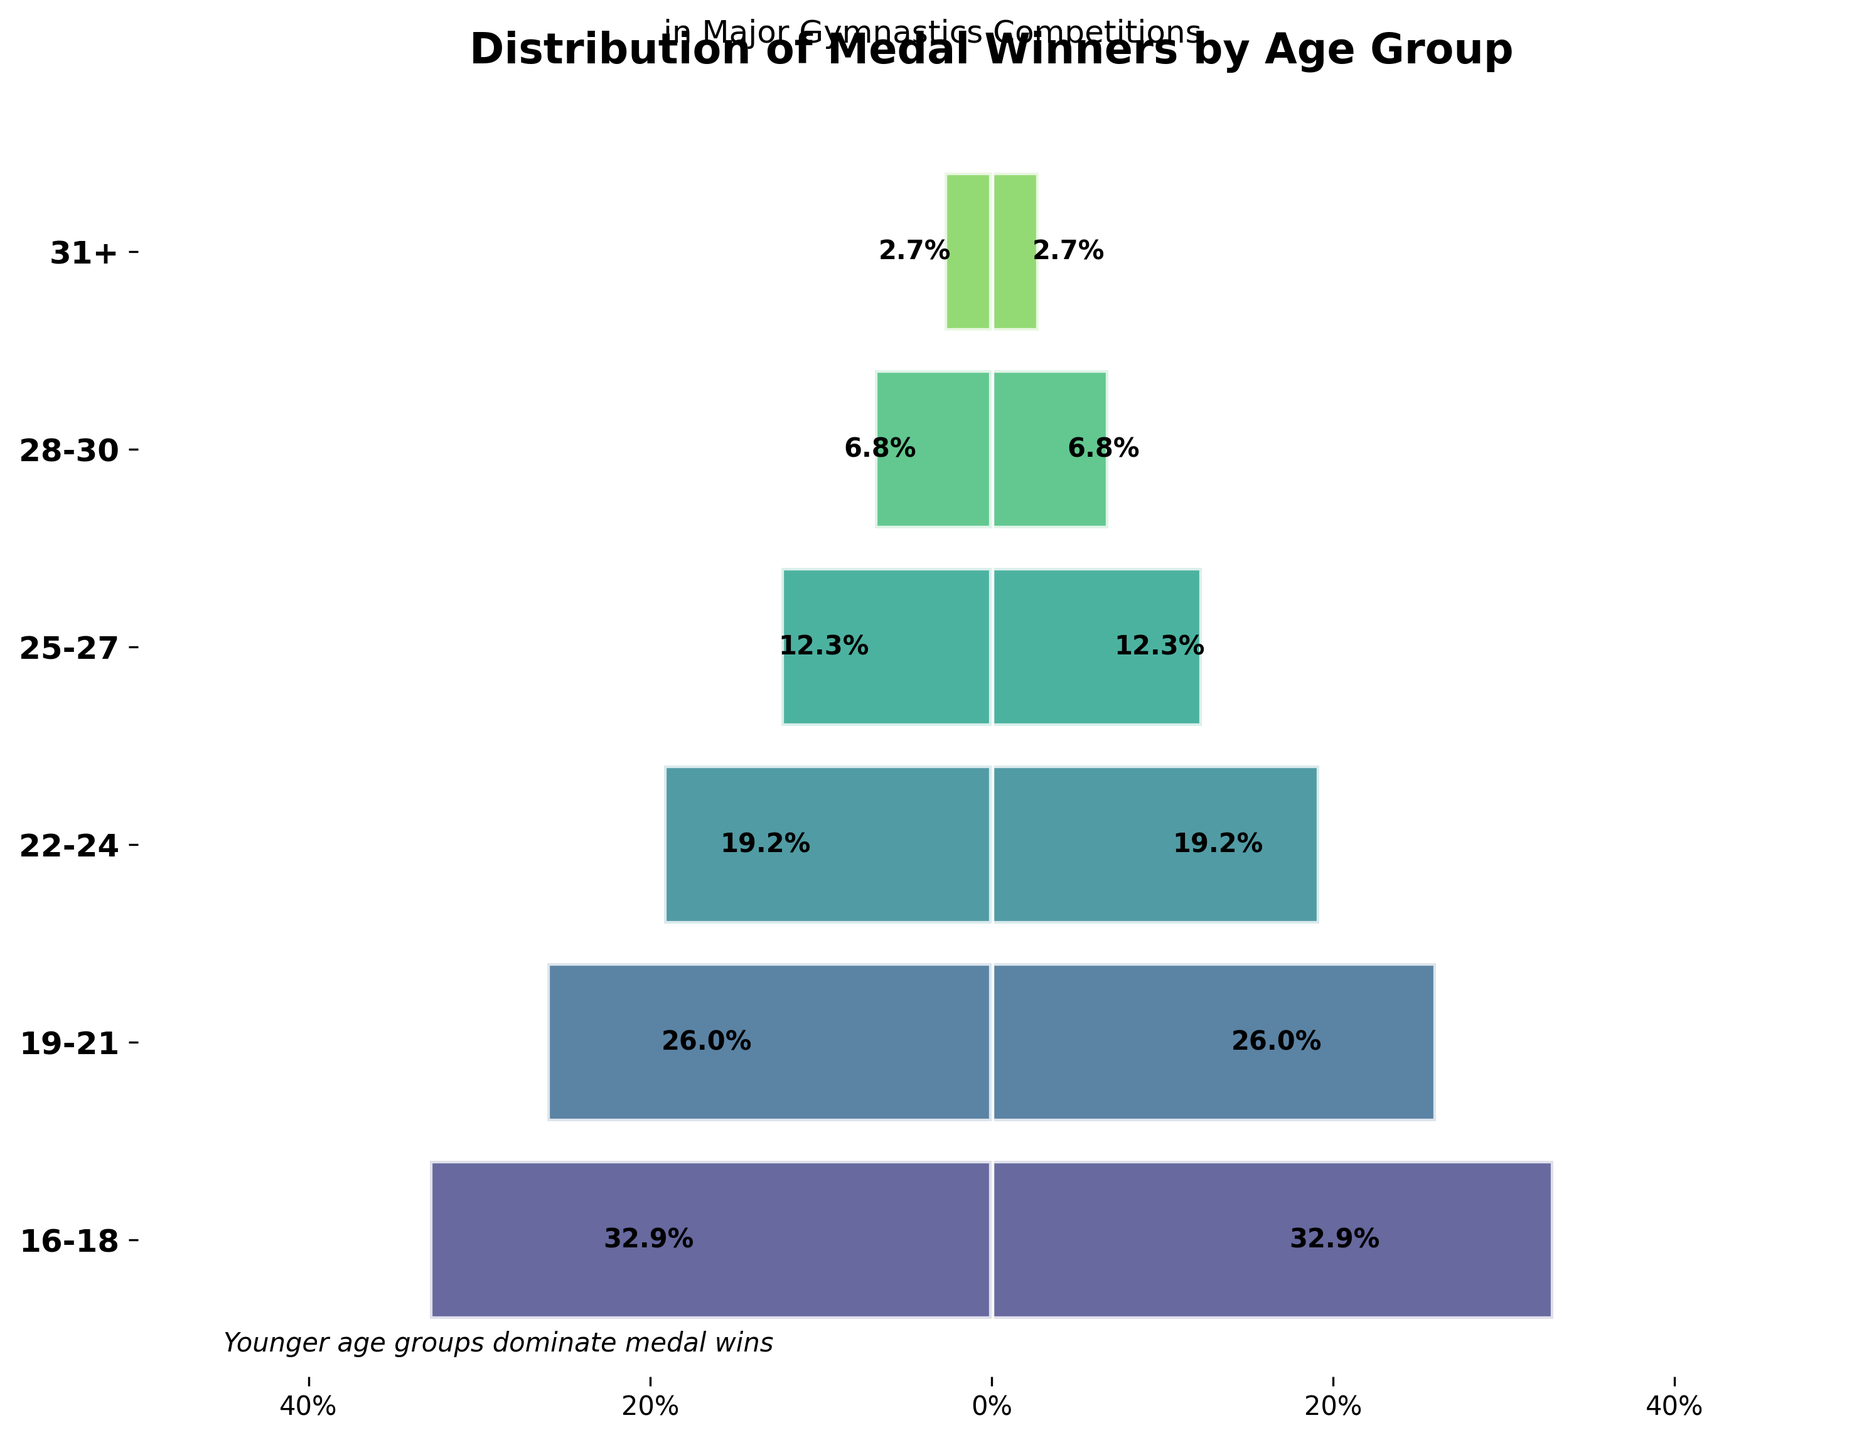What's the title of the chart? The title of the chart is displayed at the top and reads "Distribution of Medal Winners by Age Group".
Answer: Distribution of Medal Winners by Age Group Which age group has the highest percentage of medal winners? The highest percentage bar is the widest and corresponds to the age group 16-18.
Answer: 16-18 What is the percentage of medal winners in the 31+ age group? The percentage label next to the corresponding bar shows the value for the 31+ age group.
Answer: 4.7% How many age groups are depicted in the chart? Count the number of distinct horizontal bars representing different age groups.
Answer: 6 What is the combined percentage of medal winners for the age groups 22-24 and 25-27? Add the percentages for age groups 22-24 and 25-27: 22.1% + 14.2%.
Answer: 36.3% How does the percentage of medal winners in the 19-21 age group compare to the 28-30 age group? Compare the widths and the labels of the bars for age groups 19-21 and 28-30: 36.6% is higher than 9.7%.
Answer: Higher Which age group represents approximately one-fourth of the total medal winners? Look for the group with close to 25% from the labels, which is the 22-24 age group.
Answer: 22-24 What is the approximate percentage difference between the age group with the most medal winners and the age group with the least? Subtract the percentage of the least from the most: 37.7% - 4.7%.
Answer: 33% What can you infer about the trend of medal winners' ages in major gymnastics competitions? The widest bars, indicating the highest percentages, are at the top, showing that younger age groups (16-21) dominate the medal wins.
Answer: Younger ages dominate 